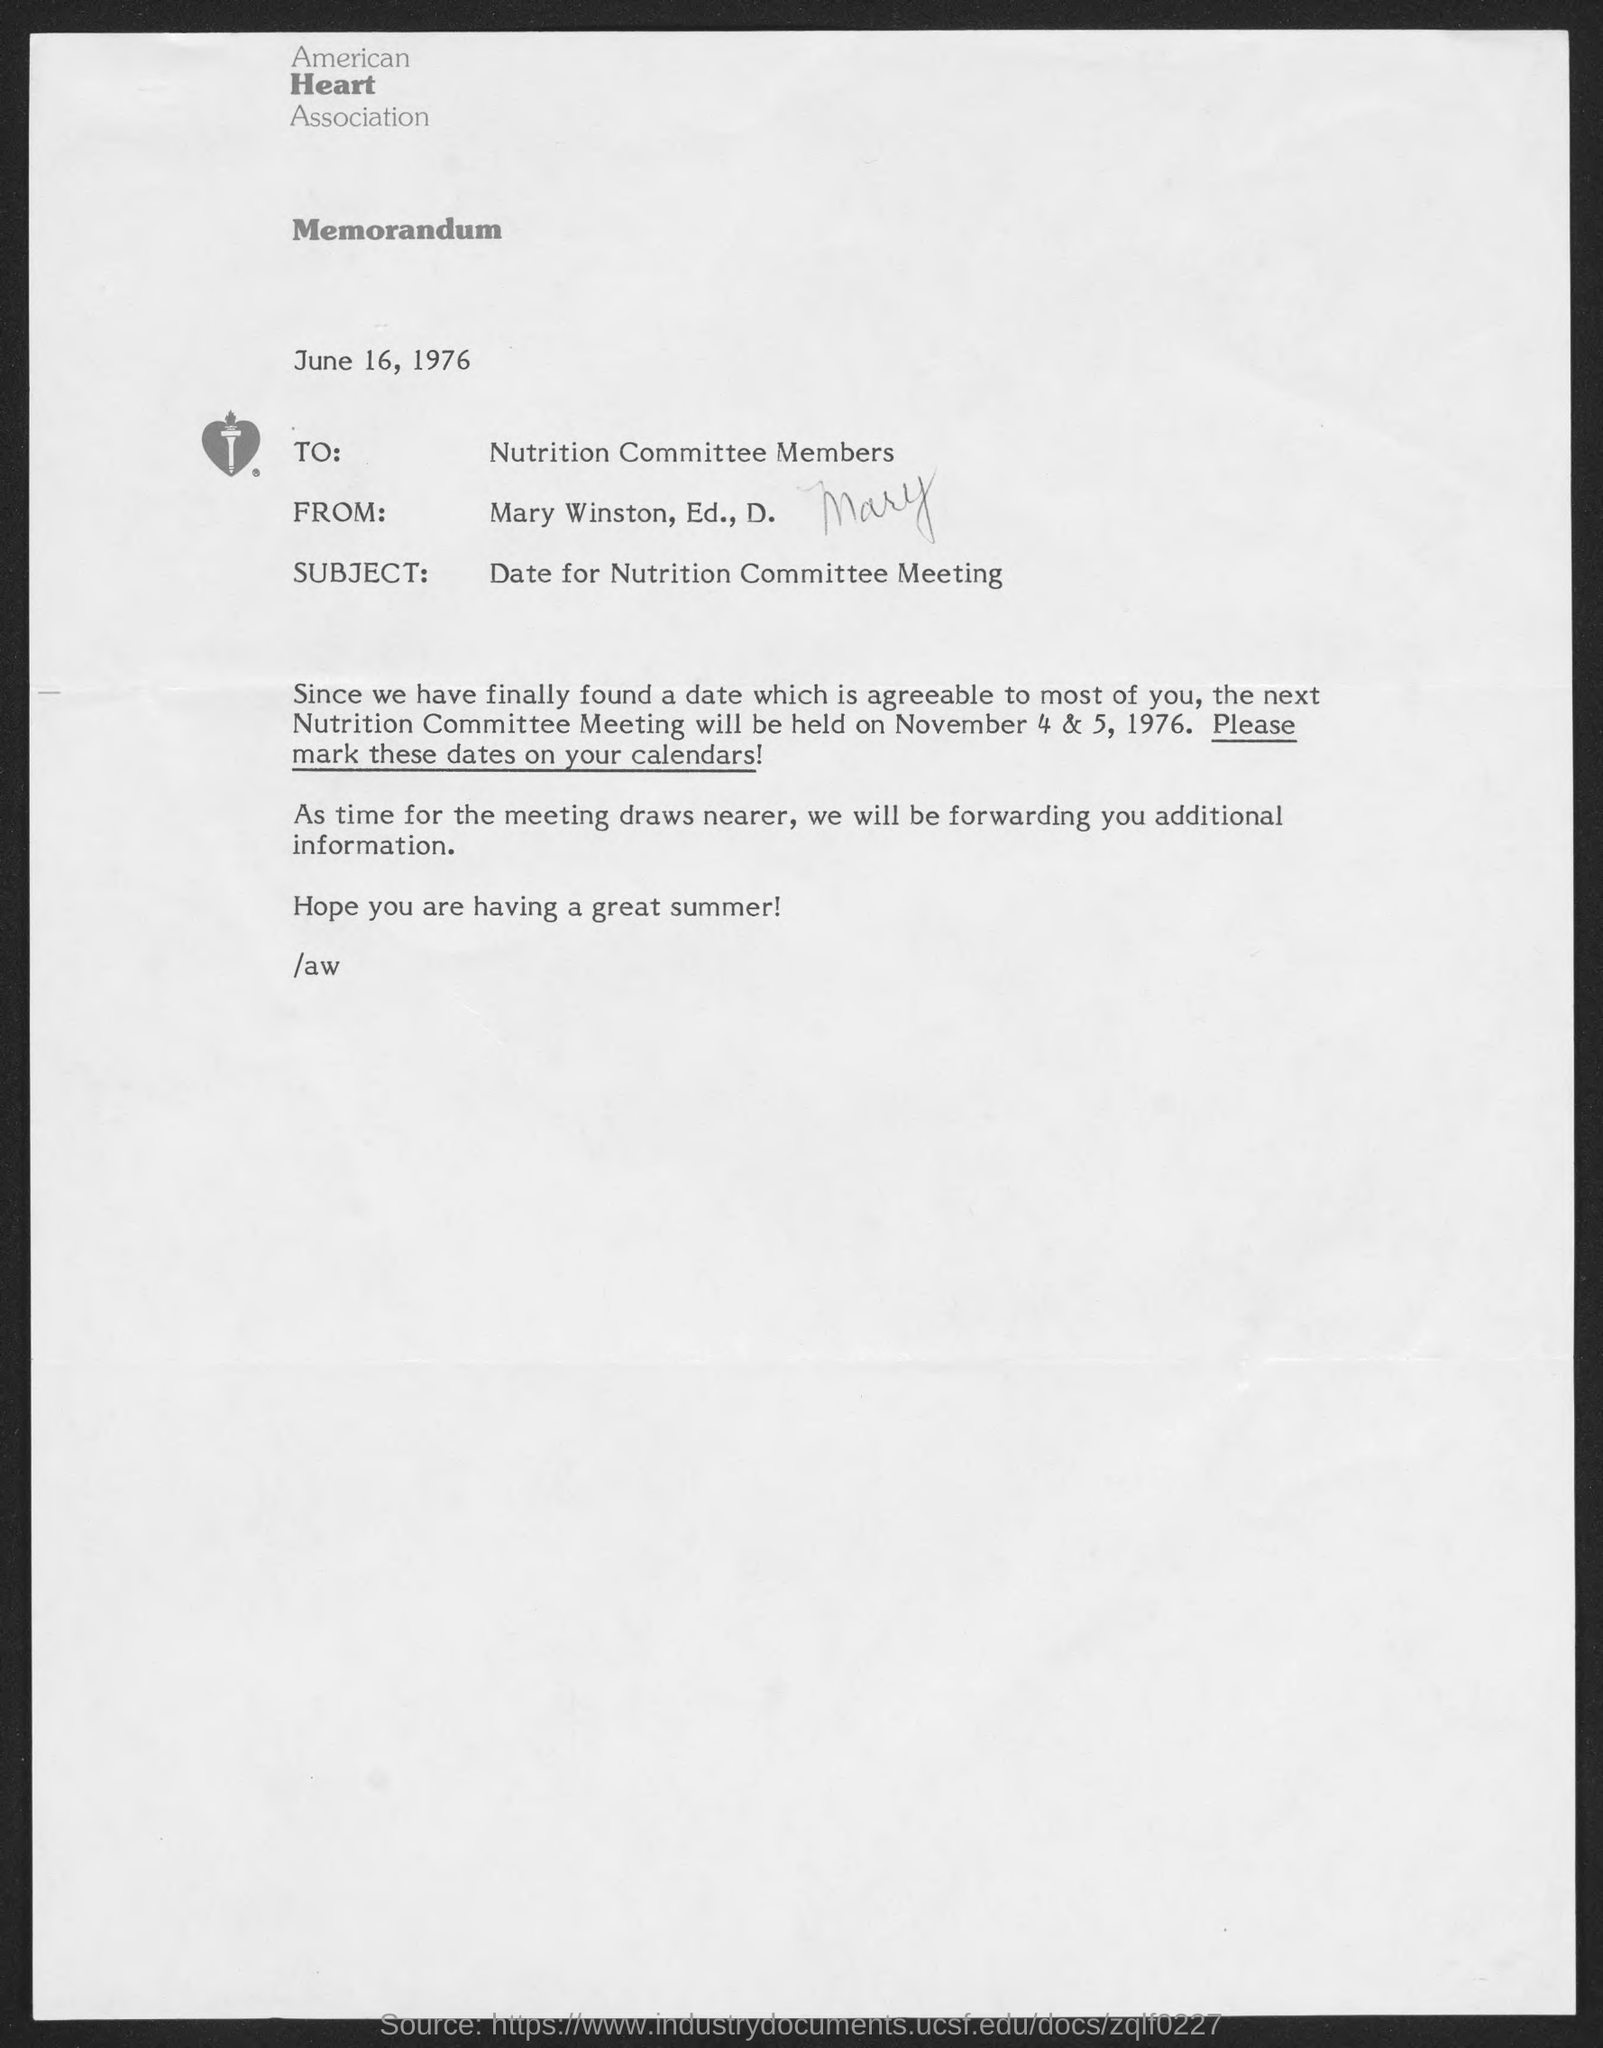What is the name of the heart association at top of the page ?
Ensure brevity in your answer.  American Heart Association. When is the memorandum dated?
Give a very brief answer. June 16, 1976. What is the subject of memorandum ?
Provide a short and direct response. Date for Nutrition Committee Meeting. When will the next nutrition committee meeting be held on ?
Your answer should be very brief. November 4 & 5, 1976. 